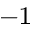<formula> <loc_0><loc_0><loc_500><loc_500>^ { - 1 }</formula> 